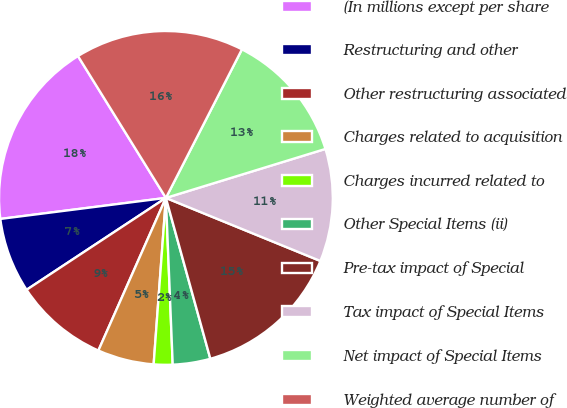Convert chart to OTSL. <chart><loc_0><loc_0><loc_500><loc_500><pie_chart><fcel>(In millions except per share<fcel>Restructuring and other<fcel>Other restructuring associated<fcel>Charges related to acquisition<fcel>Charges incurred related to<fcel>Other Special Items (ii)<fcel>Pre-tax impact of Special<fcel>Tax impact of Special Items<fcel>Net impact of Special Items<fcel>Weighted average number of<nl><fcel>18.18%<fcel>7.27%<fcel>9.09%<fcel>5.46%<fcel>1.82%<fcel>3.64%<fcel>14.54%<fcel>10.91%<fcel>12.73%<fcel>16.36%<nl></chart> 